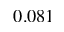Convert formula to latex. <formula><loc_0><loc_0><loc_500><loc_500>0 . 0 8 1</formula> 